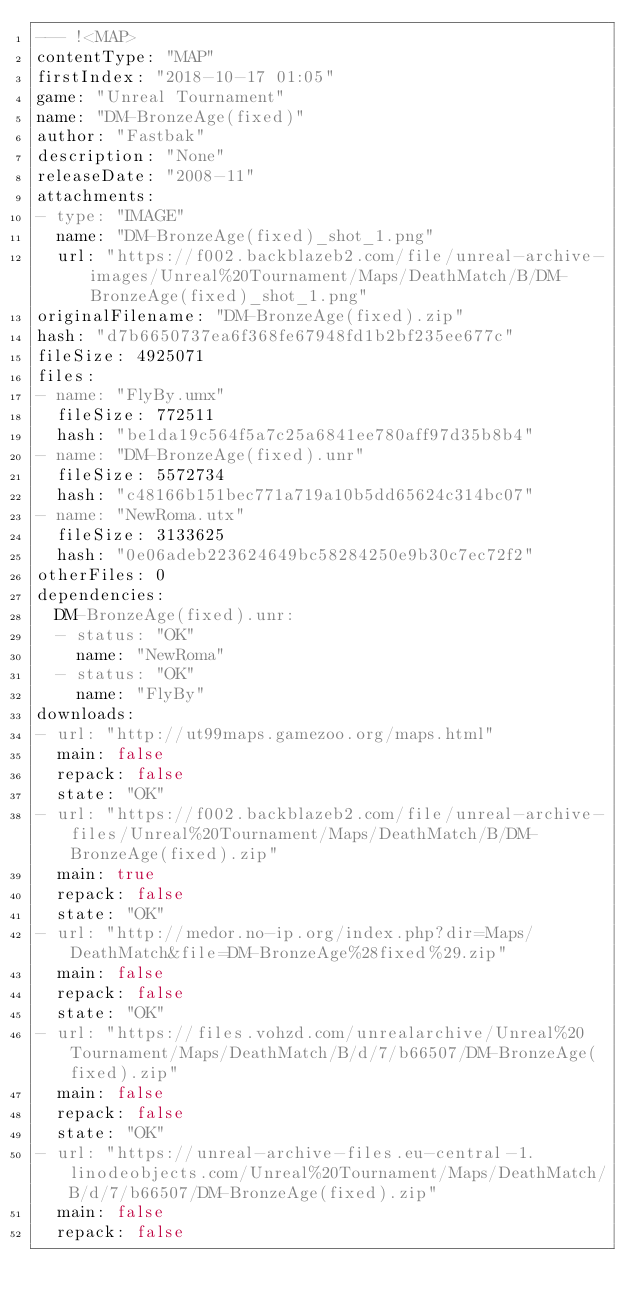Convert code to text. <code><loc_0><loc_0><loc_500><loc_500><_YAML_>--- !<MAP>
contentType: "MAP"
firstIndex: "2018-10-17 01:05"
game: "Unreal Tournament"
name: "DM-BronzeAge(fixed)"
author: "Fastbak"
description: "None"
releaseDate: "2008-11"
attachments:
- type: "IMAGE"
  name: "DM-BronzeAge(fixed)_shot_1.png"
  url: "https://f002.backblazeb2.com/file/unreal-archive-images/Unreal%20Tournament/Maps/DeathMatch/B/DM-BronzeAge(fixed)_shot_1.png"
originalFilename: "DM-BronzeAge(fixed).zip"
hash: "d7b6650737ea6f368fe67948fd1b2bf235ee677c"
fileSize: 4925071
files:
- name: "FlyBy.umx"
  fileSize: 772511
  hash: "be1da19c564f5a7c25a6841ee780aff97d35b8b4"
- name: "DM-BronzeAge(fixed).unr"
  fileSize: 5572734
  hash: "c48166b151bec771a719a10b5dd65624c314bc07"
- name: "NewRoma.utx"
  fileSize: 3133625
  hash: "0e06adeb223624649bc58284250e9b30c7ec72f2"
otherFiles: 0
dependencies:
  DM-BronzeAge(fixed).unr:
  - status: "OK"
    name: "NewRoma"
  - status: "OK"
    name: "FlyBy"
downloads:
- url: "http://ut99maps.gamezoo.org/maps.html"
  main: false
  repack: false
  state: "OK"
- url: "https://f002.backblazeb2.com/file/unreal-archive-files/Unreal%20Tournament/Maps/DeathMatch/B/DM-BronzeAge(fixed).zip"
  main: true
  repack: false
  state: "OK"
- url: "http://medor.no-ip.org/index.php?dir=Maps/DeathMatch&file=DM-BronzeAge%28fixed%29.zip"
  main: false
  repack: false
  state: "OK"
- url: "https://files.vohzd.com/unrealarchive/Unreal%20Tournament/Maps/DeathMatch/B/d/7/b66507/DM-BronzeAge(fixed).zip"
  main: false
  repack: false
  state: "OK"
- url: "https://unreal-archive-files.eu-central-1.linodeobjects.com/Unreal%20Tournament/Maps/DeathMatch/B/d/7/b66507/DM-BronzeAge(fixed).zip"
  main: false
  repack: false</code> 